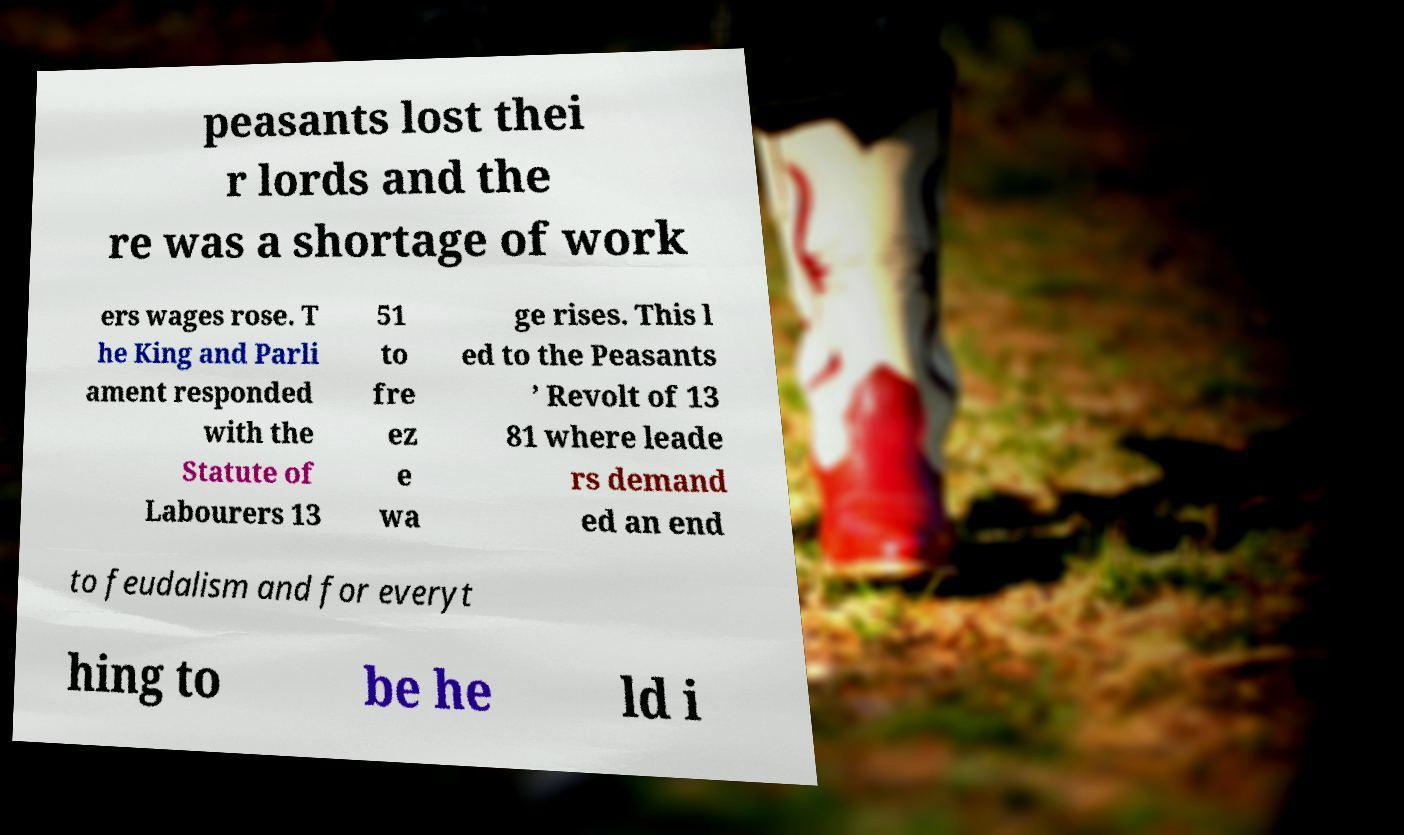Could you extract and type out the text from this image? peasants lost thei r lords and the re was a shortage of work ers wages rose. T he King and Parli ament responded with the Statute of Labourers 13 51 to fre ez e wa ge rises. This l ed to the Peasants ’ Revolt of 13 81 where leade rs demand ed an end to feudalism and for everyt hing to be he ld i 